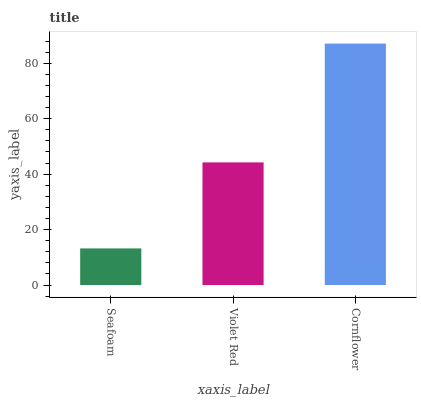Is Seafoam the minimum?
Answer yes or no. Yes. Is Cornflower the maximum?
Answer yes or no. Yes. Is Violet Red the minimum?
Answer yes or no. No. Is Violet Red the maximum?
Answer yes or no. No. Is Violet Red greater than Seafoam?
Answer yes or no. Yes. Is Seafoam less than Violet Red?
Answer yes or no. Yes. Is Seafoam greater than Violet Red?
Answer yes or no. No. Is Violet Red less than Seafoam?
Answer yes or no. No. Is Violet Red the high median?
Answer yes or no. Yes. Is Violet Red the low median?
Answer yes or no. Yes. Is Seafoam the high median?
Answer yes or no. No. Is Cornflower the low median?
Answer yes or no. No. 